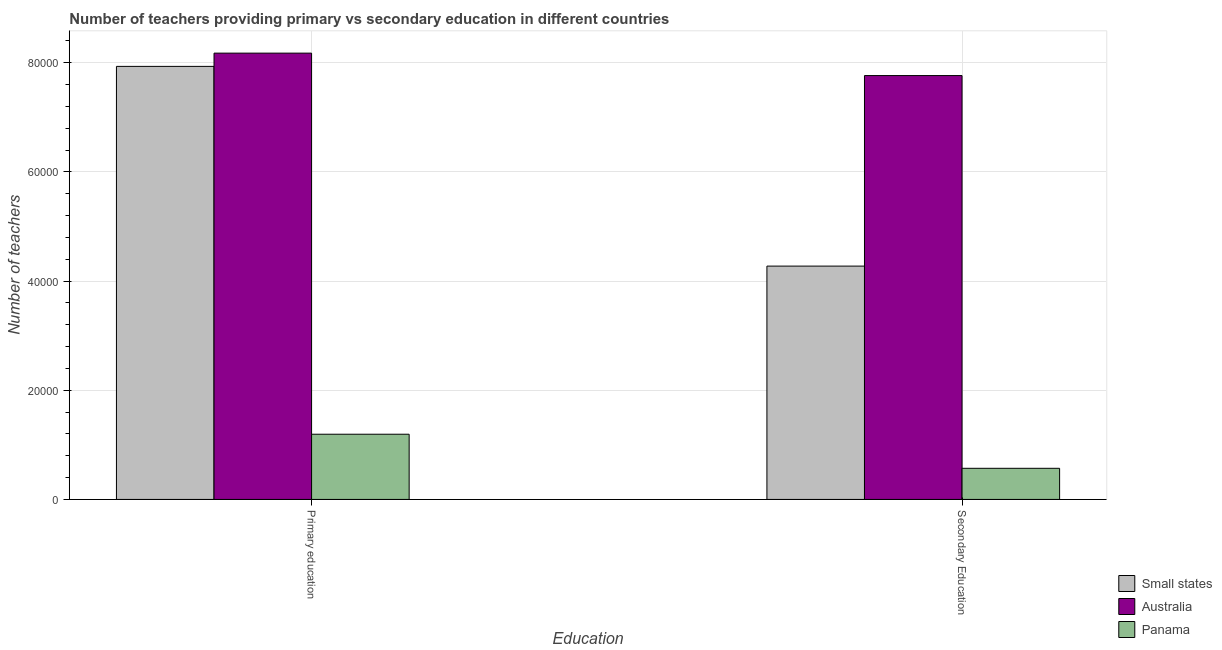Are the number of bars on each tick of the X-axis equal?
Give a very brief answer. Yes. How many bars are there on the 2nd tick from the left?
Your answer should be very brief. 3. What is the label of the 2nd group of bars from the left?
Your response must be concise. Secondary Education. What is the number of primary teachers in Panama?
Give a very brief answer. 1.19e+04. Across all countries, what is the maximum number of primary teachers?
Your answer should be compact. 8.17e+04. Across all countries, what is the minimum number of primary teachers?
Your response must be concise. 1.19e+04. In which country was the number of secondary teachers maximum?
Keep it short and to the point. Australia. In which country was the number of primary teachers minimum?
Keep it short and to the point. Panama. What is the total number of primary teachers in the graph?
Your answer should be very brief. 1.73e+05. What is the difference between the number of secondary teachers in Panama and that in Small states?
Your answer should be very brief. -3.70e+04. What is the difference between the number of primary teachers in Panama and the number of secondary teachers in Australia?
Keep it short and to the point. -6.57e+04. What is the average number of secondary teachers per country?
Offer a terse response. 4.20e+04. What is the difference between the number of secondary teachers and number of primary teachers in Panama?
Provide a short and direct response. -6242. What is the ratio of the number of secondary teachers in Panama to that in Small states?
Ensure brevity in your answer.  0.13. Is the number of secondary teachers in Small states less than that in Panama?
Ensure brevity in your answer.  No. What does the 2nd bar from the left in Secondary Education represents?
Give a very brief answer. Australia. What does the 1st bar from the right in Secondary Education represents?
Your answer should be very brief. Panama. How many bars are there?
Make the answer very short. 6. Are all the bars in the graph horizontal?
Your answer should be very brief. No. What is the difference between two consecutive major ticks on the Y-axis?
Offer a terse response. 2.00e+04. Does the graph contain grids?
Give a very brief answer. Yes. What is the title of the graph?
Offer a very short reply. Number of teachers providing primary vs secondary education in different countries. What is the label or title of the X-axis?
Your answer should be compact. Education. What is the label or title of the Y-axis?
Ensure brevity in your answer.  Number of teachers. What is the Number of teachers in Small states in Primary education?
Offer a very short reply. 7.93e+04. What is the Number of teachers of Australia in Primary education?
Your answer should be very brief. 8.17e+04. What is the Number of teachers in Panama in Primary education?
Your response must be concise. 1.19e+04. What is the Number of teachers in Small states in Secondary Education?
Ensure brevity in your answer.  4.27e+04. What is the Number of teachers in Australia in Secondary Education?
Ensure brevity in your answer.  7.76e+04. What is the Number of teachers of Panama in Secondary Education?
Provide a succinct answer. 5701. Across all Education, what is the maximum Number of teachers of Small states?
Provide a short and direct response. 7.93e+04. Across all Education, what is the maximum Number of teachers in Australia?
Your answer should be compact. 8.17e+04. Across all Education, what is the maximum Number of teachers of Panama?
Make the answer very short. 1.19e+04. Across all Education, what is the minimum Number of teachers of Small states?
Keep it short and to the point. 4.27e+04. Across all Education, what is the minimum Number of teachers of Australia?
Make the answer very short. 7.76e+04. Across all Education, what is the minimum Number of teachers in Panama?
Give a very brief answer. 5701. What is the total Number of teachers in Small states in the graph?
Your answer should be compact. 1.22e+05. What is the total Number of teachers of Australia in the graph?
Provide a succinct answer. 1.59e+05. What is the total Number of teachers in Panama in the graph?
Provide a short and direct response. 1.76e+04. What is the difference between the Number of teachers of Small states in Primary education and that in Secondary Education?
Keep it short and to the point. 3.66e+04. What is the difference between the Number of teachers of Australia in Primary education and that in Secondary Education?
Your answer should be very brief. 4109. What is the difference between the Number of teachers of Panama in Primary education and that in Secondary Education?
Your answer should be very brief. 6242. What is the difference between the Number of teachers in Small states in Primary education and the Number of teachers in Australia in Secondary Education?
Make the answer very short. 1684.56. What is the difference between the Number of teachers of Small states in Primary education and the Number of teachers of Panama in Secondary Education?
Provide a succinct answer. 7.36e+04. What is the difference between the Number of teachers in Australia in Primary education and the Number of teachers in Panama in Secondary Education?
Offer a very short reply. 7.60e+04. What is the average Number of teachers of Small states per Education?
Keep it short and to the point. 6.10e+04. What is the average Number of teachers in Australia per Education?
Provide a short and direct response. 7.97e+04. What is the average Number of teachers of Panama per Education?
Offer a very short reply. 8822. What is the difference between the Number of teachers of Small states and Number of teachers of Australia in Primary education?
Your answer should be very brief. -2424.44. What is the difference between the Number of teachers in Small states and Number of teachers in Panama in Primary education?
Offer a terse response. 6.74e+04. What is the difference between the Number of teachers of Australia and Number of teachers of Panama in Primary education?
Offer a very short reply. 6.98e+04. What is the difference between the Number of teachers in Small states and Number of teachers in Australia in Secondary Education?
Ensure brevity in your answer.  -3.49e+04. What is the difference between the Number of teachers in Small states and Number of teachers in Panama in Secondary Education?
Provide a short and direct response. 3.70e+04. What is the difference between the Number of teachers in Australia and Number of teachers in Panama in Secondary Education?
Your response must be concise. 7.19e+04. What is the ratio of the Number of teachers of Small states in Primary education to that in Secondary Education?
Provide a short and direct response. 1.86. What is the ratio of the Number of teachers in Australia in Primary education to that in Secondary Education?
Your response must be concise. 1.05. What is the ratio of the Number of teachers of Panama in Primary education to that in Secondary Education?
Offer a terse response. 2.09. What is the difference between the highest and the second highest Number of teachers of Small states?
Provide a short and direct response. 3.66e+04. What is the difference between the highest and the second highest Number of teachers in Australia?
Your response must be concise. 4109. What is the difference between the highest and the second highest Number of teachers of Panama?
Your response must be concise. 6242. What is the difference between the highest and the lowest Number of teachers of Small states?
Your answer should be very brief. 3.66e+04. What is the difference between the highest and the lowest Number of teachers of Australia?
Your answer should be compact. 4109. What is the difference between the highest and the lowest Number of teachers in Panama?
Offer a very short reply. 6242. 